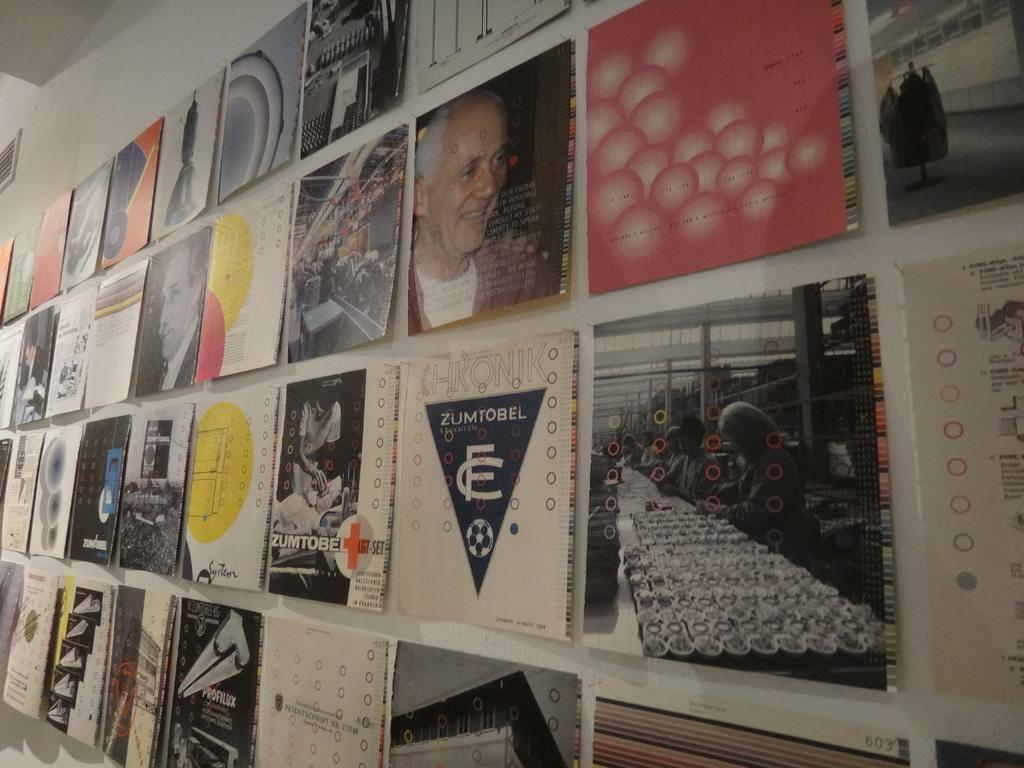Provide a one-sentence caption for the provided image. Different poster designs, two of which are Zumtobel, are hung on a wall. 